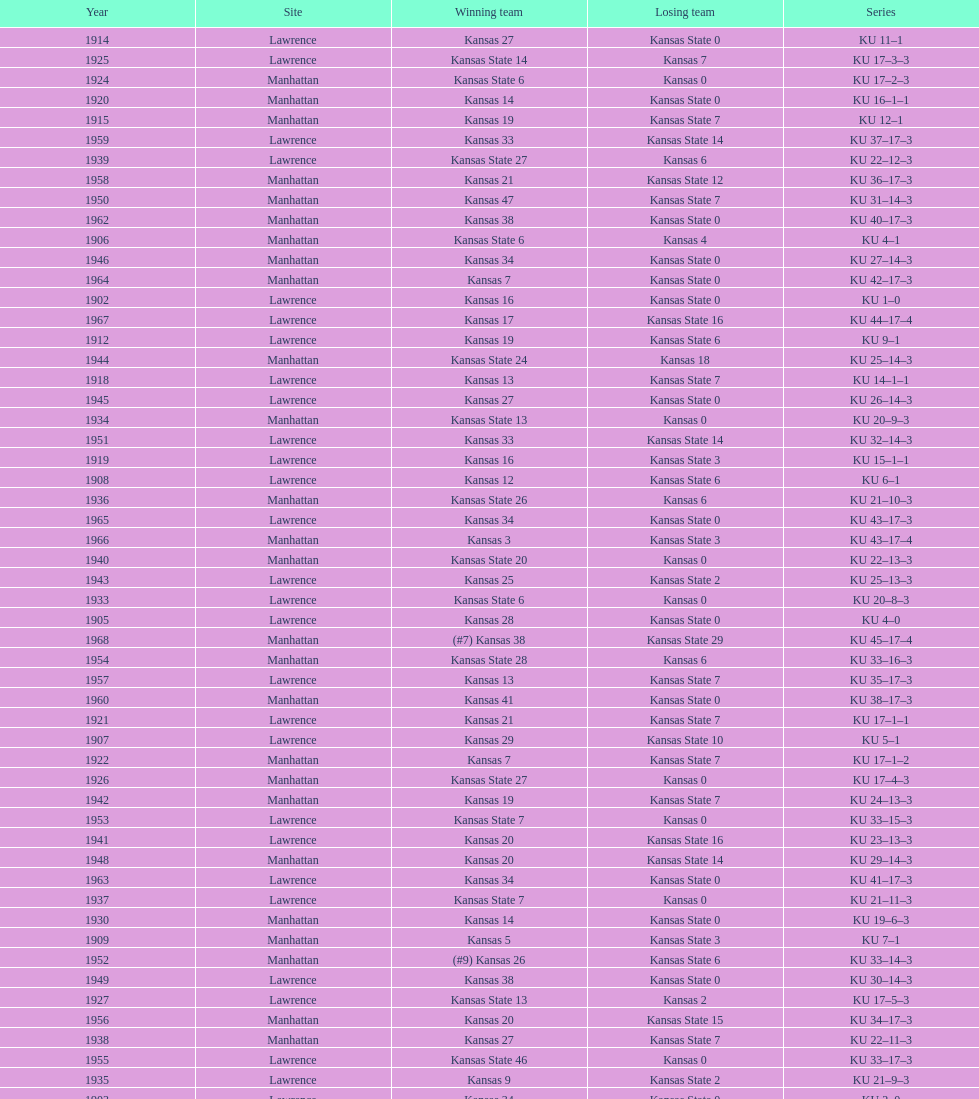When was the first game that kansas state won by double digits? 1926. 